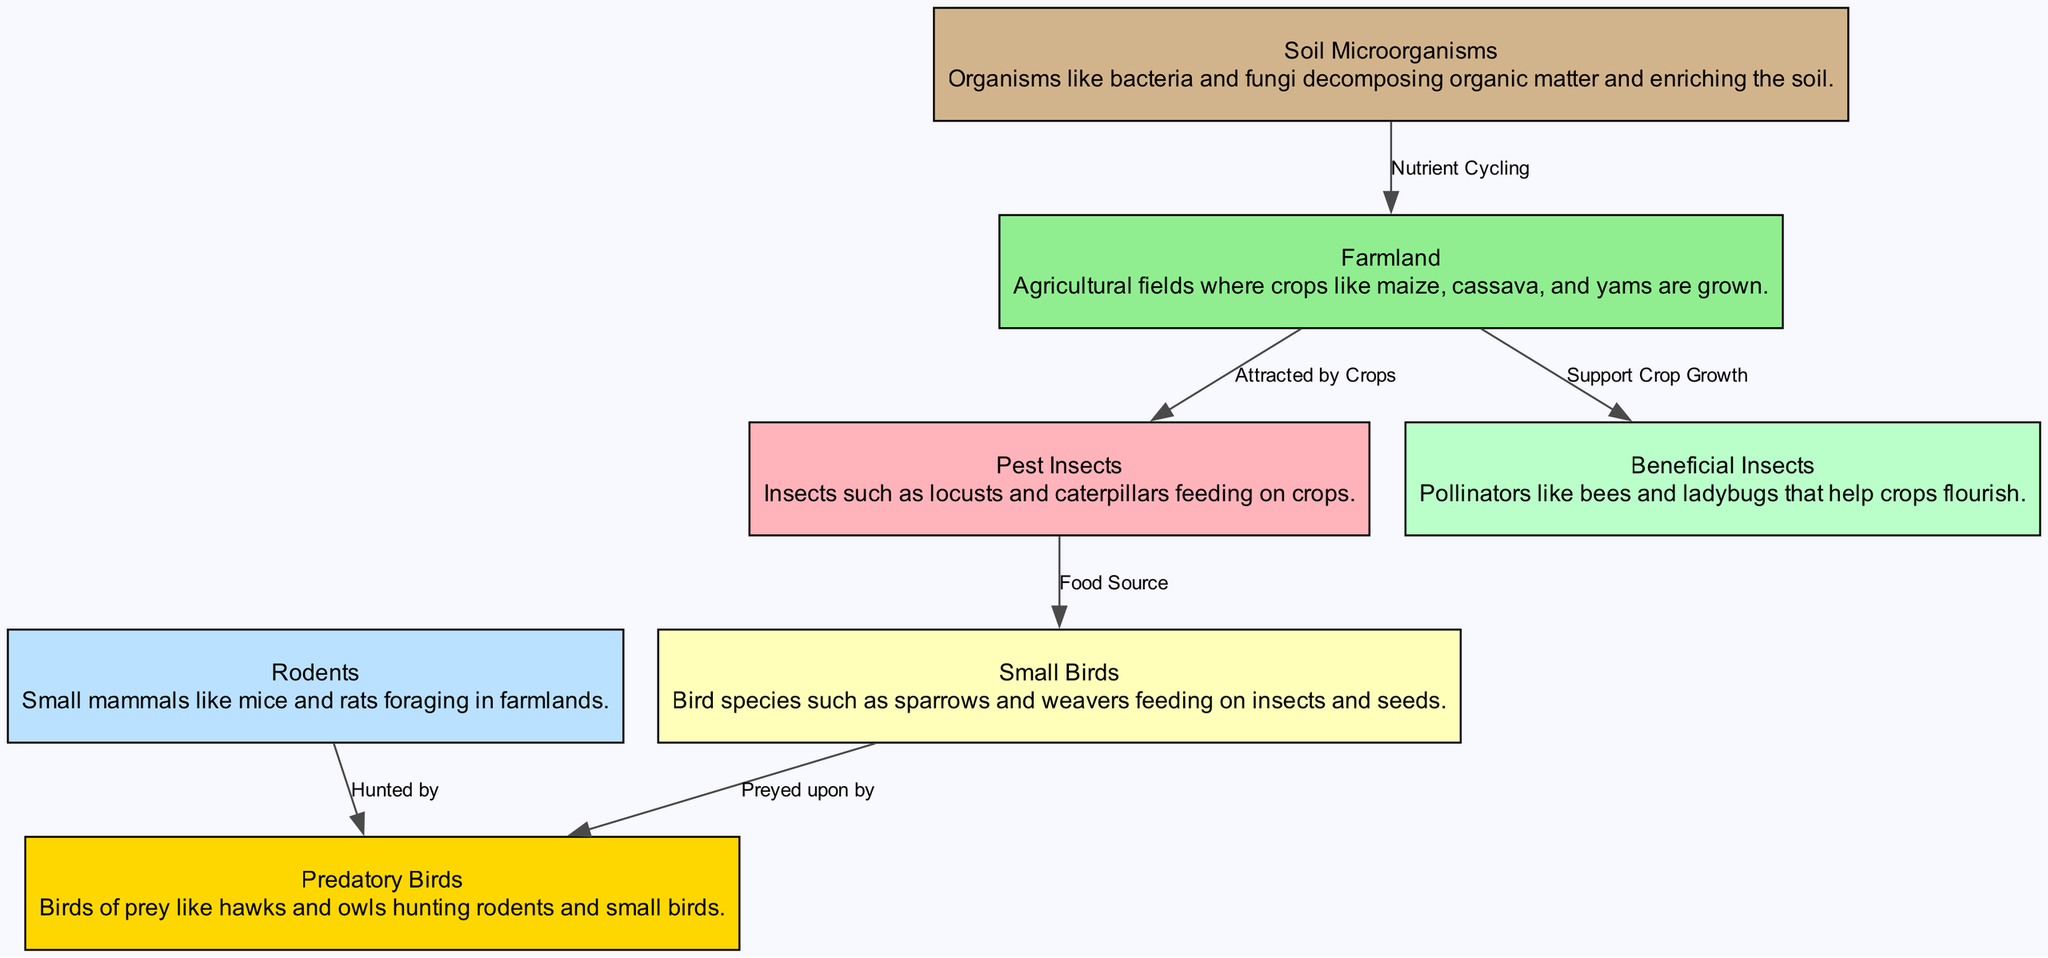What is the total number of nodes in the diagram? The diagram lists seven distinct elements as nodes: farmland, pest insects, beneficial insects, rodents, small birds, predatory birds, and soil microorganisms. Thus, the total number of nodes is seven.
Answer: 7 What relationship exists between farmland and beneficial insects? The edge connecting farmland to beneficial insects is labeled "Support Crop Growth," indicating that beneficial insects play a crucial role in enhancing the health of crops found in farmland.
Answer: Support Crop Growth Which node is a food source for small birds? The diagram shows a direct relationship with an edge from pest insects to small birds, labeled "Food Source," thus identifying pest insects as a primary food source for small birds.
Answer: Pest Insects How many types of birds are present in the diagram? The diagram features two distinct types of birds: small birds and predatory birds, which are identified as two separate nodes.
Answer: 2 What do soil microorganisms provide to farmland? The edge labeled "Nutrient Cycling" illustrates that soil microorganisms contribute to enriching farmland by cycling nutrients, thus enhancing soil quality and fertility.
Answer: Nutrient Cycling How many edges connect the nodes in the diagram? By examining the diagram, we can identify six distinct edges that represent the relationships between nodes, thus providing insight into the interactions among various elements in the food chain.
Answer: 6 Which insect group is hunted by predatory birds in the diagram? The diagram illustrates a direct edge from rodents to predatory birds, labeled "Hunted by," indicating that predatory birds prey specifically on rodents within the food chain setup.
Answer: Rodents Which beneficial role do beneficial insects have in farmland? Beneficial insects are shown to have a supportive role in crop growth, as indicated by the edge labeled "Support Crop Growth," which connects them directly to farmland in the diagram.
Answer: Support Crop Growth Which type of bird preys on small birds in the diagram? The edge indicated in the diagram from small birds to predatory birds, which is labeled "Preyed upon by," shows that predatory birds are the species that hunt small birds for food.
Answer: Predatory Birds 